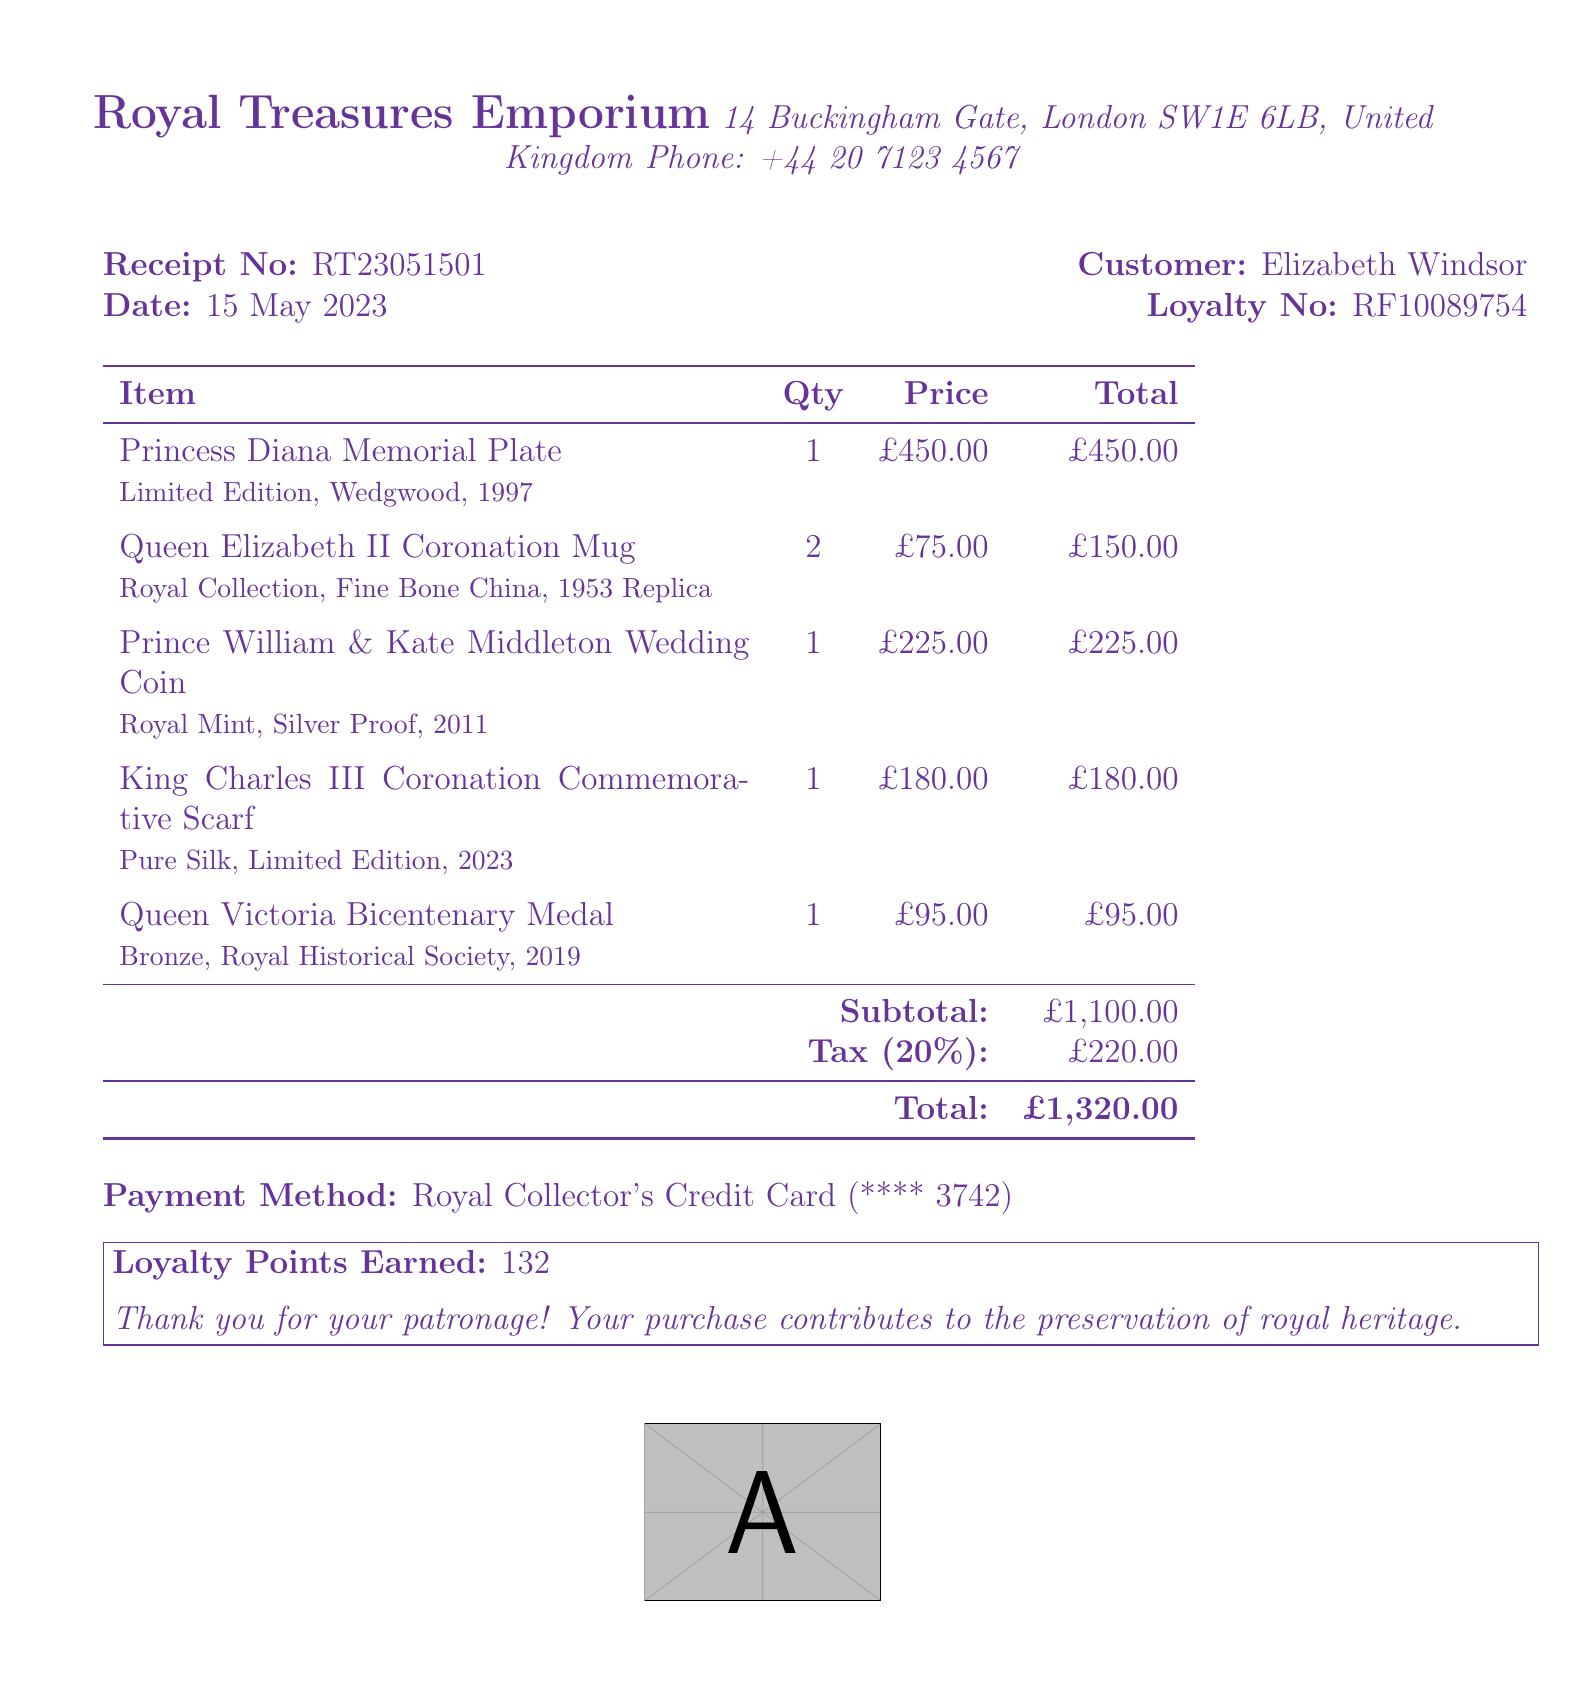What is the receipt number? The receipt number can be found in the document, listed as RT23051501.
Answer: RT23051501 Who is the customer? The document identifies the customer as Elizabeth Windsor.
Answer: Elizabeth Windsor What is the date of the purchase? The purchase date is mentioned as 15 May 2023 in the receipt.
Answer: 15 May 2023 What item has the highest price? The item with the highest price is the Princess Diana Memorial Plate, priced at £450.00.
Answer: Princess Diana Memorial Plate What is the total amount paid? The total amount paid is calculated at the bottom of the receipt as £1,320.00.
Answer: £1,320.00 How many Queen Elizabeth II Coronation Mugs were purchased? The purchase quantity for Queen Elizabeth II Coronation Mugs is listed as 2.
Answer: 2 What is the subtotal before tax? The subtotal before tax is shown as £1,100.00 in the document.
Answer: £1,100.00 What is the tax rate applied? The document states the tax rate applied is 20%.
Answer: 20% What is the payment method used? The payment method is described as Royal Collector's Credit Card.
Answer: Royal Collector's Credit Card 